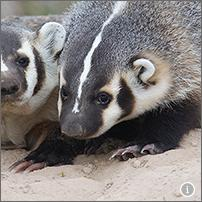Which animal's feet are also adapted for digging? six-banded armadillo why? An adaptation is an inherited trait that helps an organism survive or reproduce. Adaptations can include both body parts and behaviors.
The shape of an animal's feet is one example of an adaptation. Animals' feet can be adapted in different ways. For example, webbed feet might help an animal swim. Feet with thick fur might help an animal walk on cold, snowy ground. Look at the picture of the American badger.
The American badger has long, straight claws. Its feet are adapted for digging. The American badger uses its claws to break up soil and move it out of the way.
Now look at each animal. Figure out which animal has a similar adaptation.
The six-banded armadillo has long, straight claws. Its feet are adapted for digging.
The Weddell seal has small flippers for feet. Its feet are not adapted for digging. The Weddell seal uses its flippers to crawl and swim. 